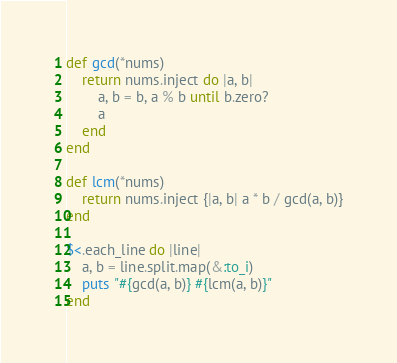Convert code to text. <code><loc_0><loc_0><loc_500><loc_500><_Ruby_>def gcd(*nums)
	return nums.inject do |a, b|
		a, b = b, a % b until b.zero?
		a
	end
end

def lcm(*nums)
	return nums.inject {|a, b| a * b / gcd(a, b)}
end

$<.each_line do |line|
	a, b = line.split.map(&:to_i)
	puts "#{gcd(a, b)} #{lcm(a, b)}"
end</code> 